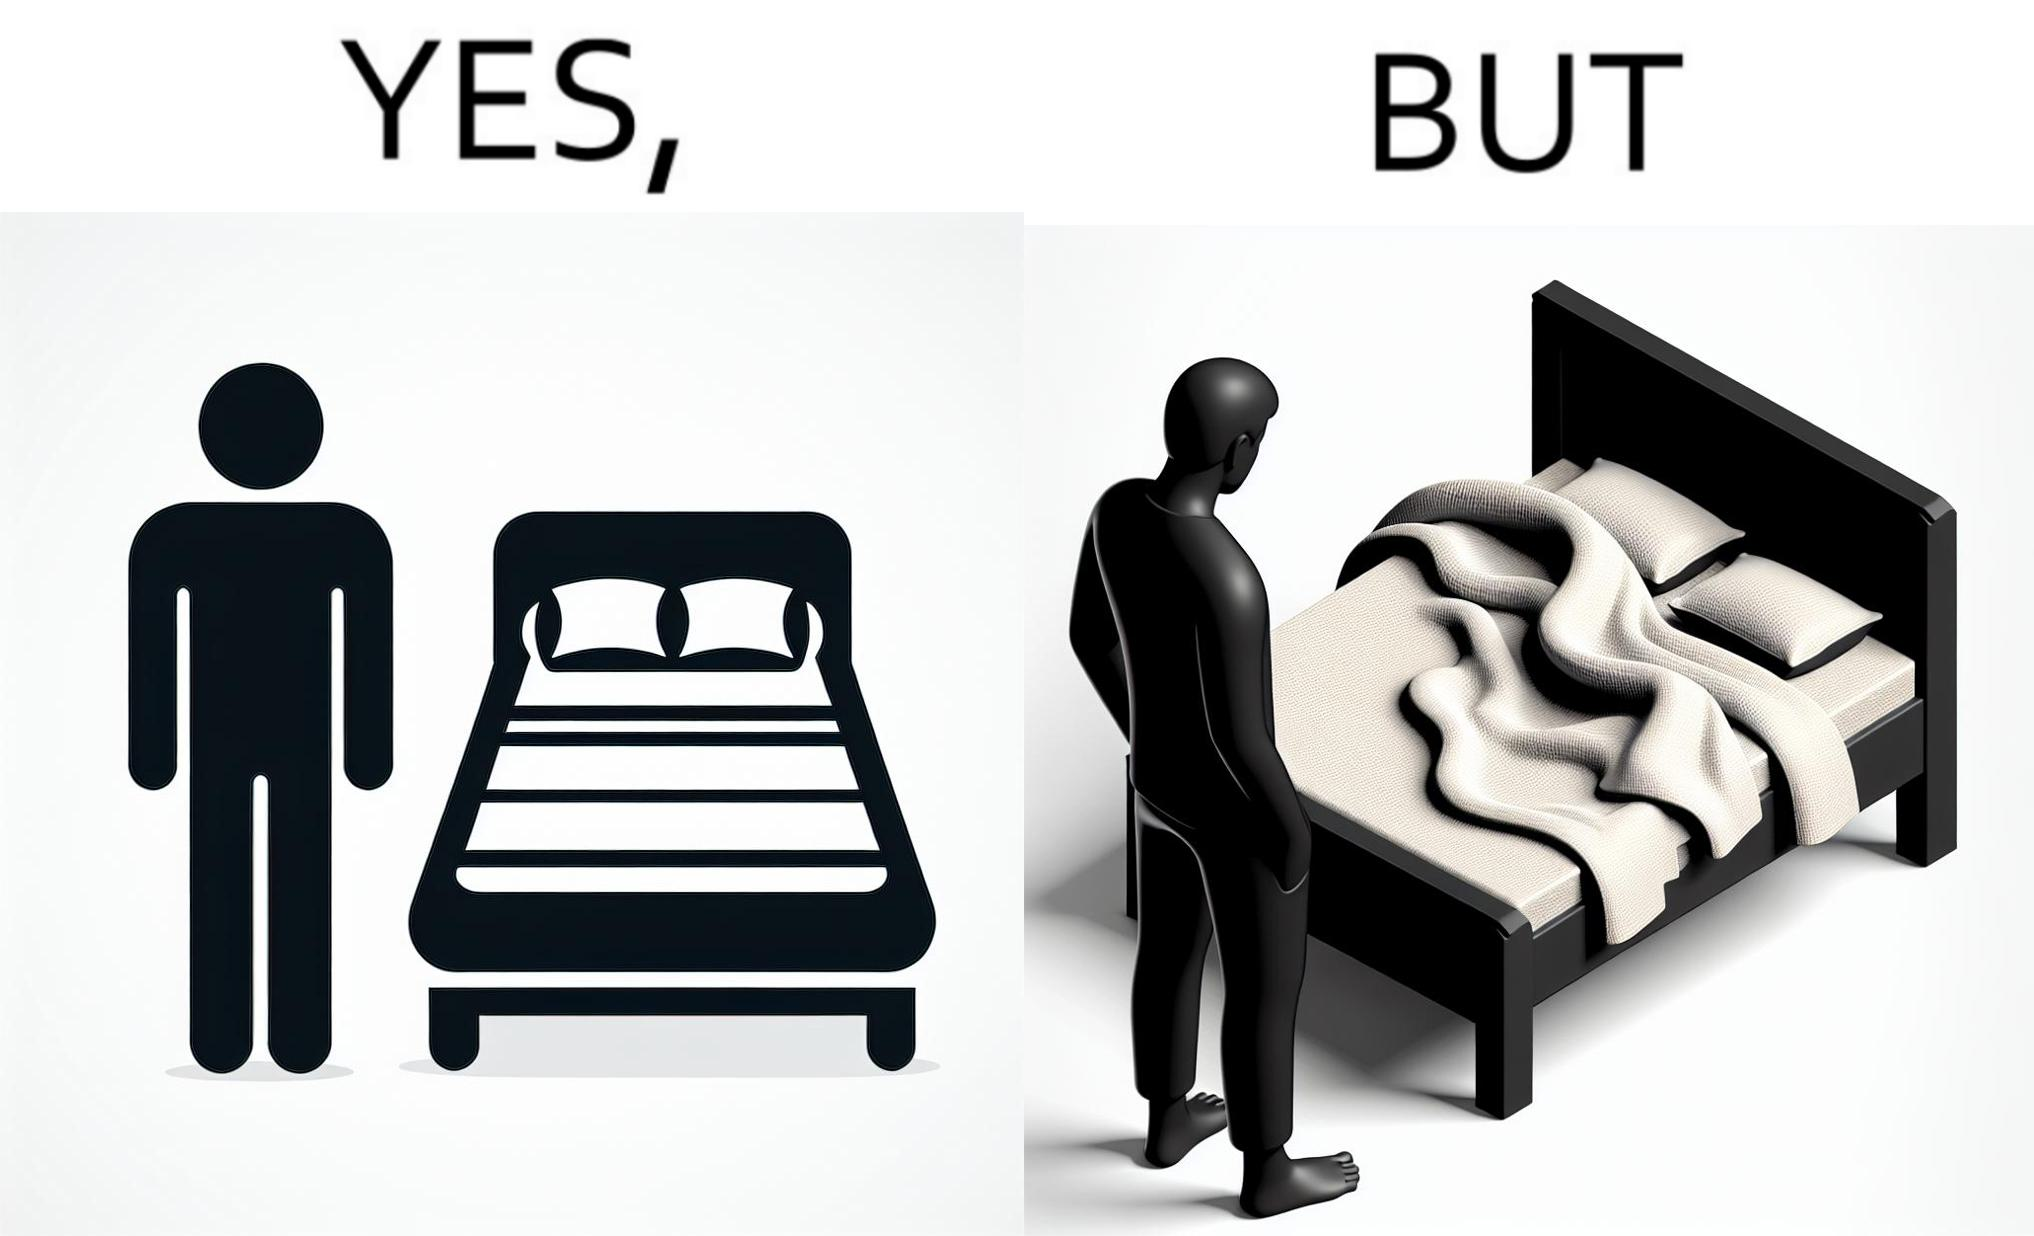Describe what you see in this image. The image is funny because while the bed seems to be well made with the blanket on top, the actual blanket inside the blanket cover is twisted and not properly set. 